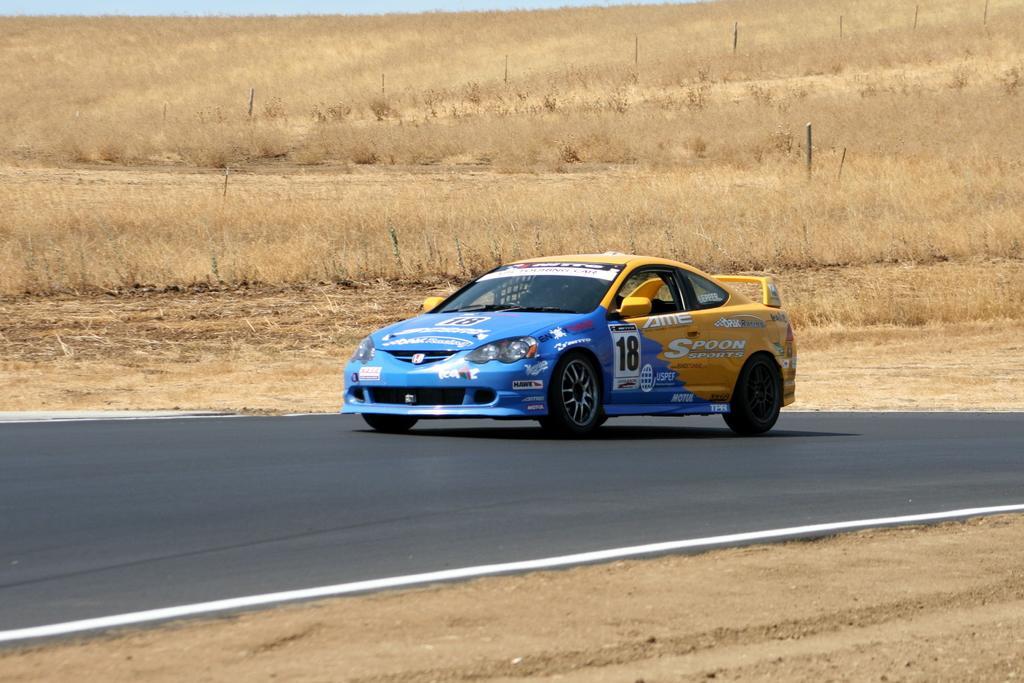In one or two sentences, can you explain what this image depicts? In the center of the image we can see a car. In the background of the image we can see the dry grass and poles. At the top of the image we can see the sky. In the middle of the image we can see the road. At the bottom of the image we can see the ground. 